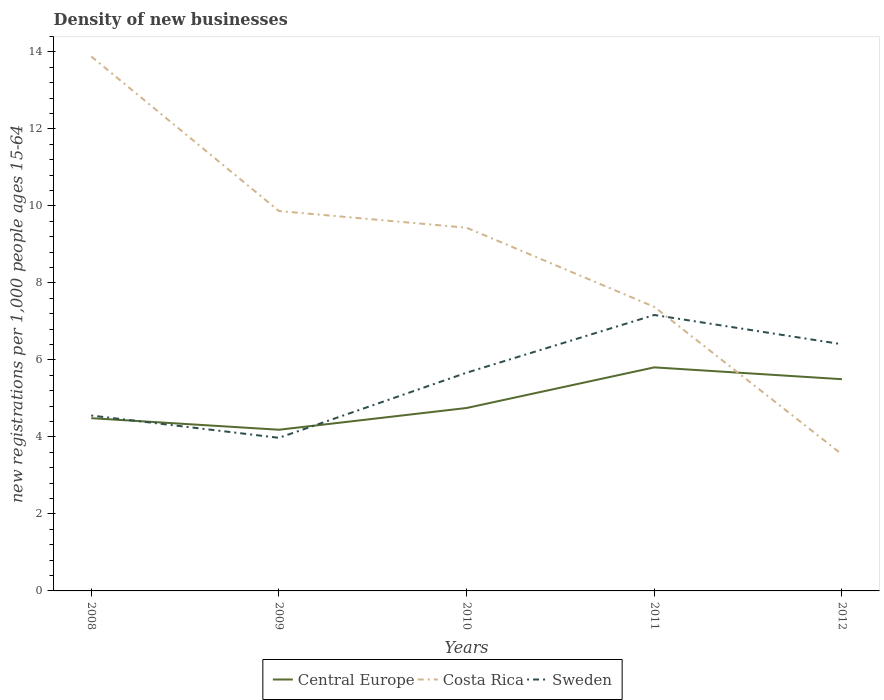How many different coloured lines are there?
Make the answer very short. 3. Does the line corresponding to Central Europe intersect with the line corresponding to Sweden?
Offer a terse response. Yes. Across all years, what is the maximum number of new registrations in Central Europe?
Make the answer very short. 4.19. What is the total number of new registrations in Central Europe in the graph?
Provide a short and direct response. -0.75. What is the difference between the highest and the second highest number of new registrations in Sweden?
Your response must be concise. 3.19. What is the difference between two consecutive major ticks on the Y-axis?
Provide a short and direct response. 2. Are the values on the major ticks of Y-axis written in scientific E-notation?
Give a very brief answer. No. Does the graph contain any zero values?
Give a very brief answer. No. Does the graph contain grids?
Provide a succinct answer. No. How many legend labels are there?
Offer a terse response. 3. What is the title of the graph?
Your response must be concise. Density of new businesses. What is the label or title of the Y-axis?
Ensure brevity in your answer.  New registrations per 1,0 people ages 15-64. What is the new registrations per 1,000 people ages 15-64 of Central Europe in 2008?
Make the answer very short. 4.49. What is the new registrations per 1,000 people ages 15-64 of Costa Rica in 2008?
Your answer should be compact. 13.88. What is the new registrations per 1,000 people ages 15-64 of Sweden in 2008?
Give a very brief answer. 4.56. What is the new registrations per 1,000 people ages 15-64 in Central Europe in 2009?
Ensure brevity in your answer.  4.19. What is the new registrations per 1,000 people ages 15-64 of Costa Rica in 2009?
Your answer should be very brief. 9.87. What is the new registrations per 1,000 people ages 15-64 in Sweden in 2009?
Offer a terse response. 3.98. What is the new registrations per 1,000 people ages 15-64 of Central Europe in 2010?
Your response must be concise. 4.75. What is the new registrations per 1,000 people ages 15-64 in Costa Rica in 2010?
Keep it short and to the point. 9.44. What is the new registrations per 1,000 people ages 15-64 in Sweden in 2010?
Offer a terse response. 5.67. What is the new registrations per 1,000 people ages 15-64 in Central Europe in 2011?
Keep it short and to the point. 5.81. What is the new registrations per 1,000 people ages 15-64 in Costa Rica in 2011?
Your answer should be very brief. 7.38. What is the new registrations per 1,000 people ages 15-64 in Sweden in 2011?
Your response must be concise. 7.17. What is the new registrations per 1,000 people ages 15-64 in Central Europe in 2012?
Give a very brief answer. 5.5. What is the new registrations per 1,000 people ages 15-64 of Costa Rica in 2012?
Make the answer very short. 3.55. What is the new registrations per 1,000 people ages 15-64 in Sweden in 2012?
Your answer should be compact. 6.41. Across all years, what is the maximum new registrations per 1,000 people ages 15-64 in Central Europe?
Offer a terse response. 5.81. Across all years, what is the maximum new registrations per 1,000 people ages 15-64 in Costa Rica?
Offer a very short reply. 13.88. Across all years, what is the maximum new registrations per 1,000 people ages 15-64 in Sweden?
Provide a short and direct response. 7.17. Across all years, what is the minimum new registrations per 1,000 people ages 15-64 in Central Europe?
Offer a terse response. 4.19. Across all years, what is the minimum new registrations per 1,000 people ages 15-64 of Costa Rica?
Make the answer very short. 3.55. Across all years, what is the minimum new registrations per 1,000 people ages 15-64 in Sweden?
Your answer should be compact. 3.98. What is the total new registrations per 1,000 people ages 15-64 of Central Europe in the graph?
Provide a succinct answer. 24.73. What is the total new registrations per 1,000 people ages 15-64 of Costa Rica in the graph?
Make the answer very short. 44.11. What is the total new registrations per 1,000 people ages 15-64 in Sweden in the graph?
Your answer should be compact. 27.78. What is the difference between the new registrations per 1,000 people ages 15-64 of Central Europe in 2008 and that in 2009?
Your answer should be very brief. 0.3. What is the difference between the new registrations per 1,000 people ages 15-64 of Costa Rica in 2008 and that in 2009?
Make the answer very short. 4.01. What is the difference between the new registrations per 1,000 people ages 15-64 of Sweden in 2008 and that in 2009?
Ensure brevity in your answer.  0.58. What is the difference between the new registrations per 1,000 people ages 15-64 in Central Europe in 2008 and that in 2010?
Offer a terse response. -0.26. What is the difference between the new registrations per 1,000 people ages 15-64 of Costa Rica in 2008 and that in 2010?
Your answer should be very brief. 4.45. What is the difference between the new registrations per 1,000 people ages 15-64 in Sweden in 2008 and that in 2010?
Offer a very short reply. -1.11. What is the difference between the new registrations per 1,000 people ages 15-64 in Central Europe in 2008 and that in 2011?
Offer a terse response. -1.32. What is the difference between the new registrations per 1,000 people ages 15-64 in Costa Rica in 2008 and that in 2011?
Offer a very short reply. 6.5. What is the difference between the new registrations per 1,000 people ages 15-64 of Sweden in 2008 and that in 2011?
Your response must be concise. -2.61. What is the difference between the new registrations per 1,000 people ages 15-64 in Central Europe in 2008 and that in 2012?
Make the answer very short. -1.01. What is the difference between the new registrations per 1,000 people ages 15-64 of Costa Rica in 2008 and that in 2012?
Make the answer very short. 10.34. What is the difference between the new registrations per 1,000 people ages 15-64 of Sweden in 2008 and that in 2012?
Provide a short and direct response. -1.85. What is the difference between the new registrations per 1,000 people ages 15-64 in Central Europe in 2009 and that in 2010?
Your answer should be very brief. -0.57. What is the difference between the new registrations per 1,000 people ages 15-64 of Costa Rica in 2009 and that in 2010?
Provide a short and direct response. 0.43. What is the difference between the new registrations per 1,000 people ages 15-64 in Sweden in 2009 and that in 2010?
Your answer should be compact. -1.69. What is the difference between the new registrations per 1,000 people ages 15-64 in Central Europe in 2009 and that in 2011?
Give a very brief answer. -1.62. What is the difference between the new registrations per 1,000 people ages 15-64 of Costa Rica in 2009 and that in 2011?
Keep it short and to the point. 2.49. What is the difference between the new registrations per 1,000 people ages 15-64 of Sweden in 2009 and that in 2011?
Give a very brief answer. -3.19. What is the difference between the new registrations per 1,000 people ages 15-64 of Central Europe in 2009 and that in 2012?
Your response must be concise. -1.31. What is the difference between the new registrations per 1,000 people ages 15-64 of Costa Rica in 2009 and that in 2012?
Give a very brief answer. 6.32. What is the difference between the new registrations per 1,000 people ages 15-64 of Sweden in 2009 and that in 2012?
Your answer should be compact. -2.43. What is the difference between the new registrations per 1,000 people ages 15-64 in Central Europe in 2010 and that in 2011?
Offer a terse response. -1.06. What is the difference between the new registrations per 1,000 people ages 15-64 of Costa Rica in 2010 and that in 2011?
Offer a terse response. 2.06. What is the difference between the new registrations per 1,000 people ages 15-64 of Sweden in 2010 and that in 2011?
Keep it short and to the point. -1.5. What is the difference between the new registrations per 1,000 people ages 15-64 in Central Europe in 2010 and that in 2012?
Make the answer very short. -0.75. What is the difference between the new registrations per 1,000 people ages 15-64 of Costa Rica in 2010 and that in 2012?
Offer a very short reply. 5.89. What is the difference between the new registrations per 1,000 people ages 15-64 in Sweden in 2010 and that in 2012?
Offer a very short reply. -0.74. What is the difference between the new registrations per 1,000 people ages 15-64 of Central Europe in 2011 and that in 2012?
Keep it short and to the point. 0.31. What is the difference between the new registrations per 1,000 people ages 15-64 in Costa Rica in 2011 and that in 2012?
Provide a succinct answer. 3.83. What is the difference between the new registrations per 1,000 people ages 15-64 of Sweden in 2011 and that in 2012?
Provide a succinct answer. 0.76. What is the difference between the new registrations per 1,000 people ages 15-64 of Central Europe in 2008 and the new registrations per 1,000 people ages 15-64 of Costa Rica in 2009?
Your response must be concise. -5.38. What is the difference between the new registrations per 1,000 people ages 15-64 of Central Europe in 2008 and the new registrations per 1,000 people ages 15-64 of Sweden in 2009?
Your answer should be very brief. 0.51. What is the difference between the new registrations per 1,000 people ages 15-64 of Costa Rica in 2008 and the new registrations per 1,000 people ages 15-64 of Sweden in 2009?
Offer a very short reply. 9.91. What is the difference between the new registrations per 1,000 people ages 15-64 of Central Europe in 2008 and the new registrations per 1,000 people ages 15-64 of Costa Rica in 2010?
Keep it short and to the point. -4.95. What is the difference between the new registrations per 1,000 people ages 15-64 in Central Europe in 2008 and the new registrations per 1,000 people ages 15-64 in Sweden in 2010?
Your answer should be very brief. -1.18. What is the difference between the new registrations per 1,000 people ages 15-64 in Costa Rica in 2008 and the new registrations per 1,000 people ages 15-64 in Sweden in 2010?
Offer a terse response. 8.21. What is the difference between the new registrations per 1,000 people ages 15-64 of Central Europe in 2008 and the new registrations per 1,000 people ages 15-64 of Costa Rica in 2011?
Offer a very short reply. -2.89. What is the difference between the new registrations per 1,000 people ages 15-64 of Central Europe in 2008 and the new registrations per 1,000 people ages 15-64 of Sweden in 2011?
Give a very brief answer. -2.68. What is the difference between the new registrations per 1,000 people ages 15-64 in Costa Rica in 2008 and the new registrations per 1,000 people ages 15-64 in Sweden in 2011?
Ensure brevity in your answer.  6.72. What is the difference between the new registrations per 1,000 people ages 15-64 in Central Europe in 2008 and the new registrations per 1,000 people ages 15-64 in Costa Rica in 2012?
Offer a very short reply. 0.94. What is the difference between the new registrations per 1,000 people ages 15-64 in Central Europe in 2008 and the new registrations per 1,000 people ages 15-64 in Sweden in 2012?
Your answer should be compact. -1.92. What is the difference between the new registrations per 1,000 people ages 15-64 of Costa Rica in 2008 and the new registrations per 1,000 people ages 15-64 of Sweden in 2012?
Offer a terse response. 7.47. What is the difference between the new registrations per 1,000 people ages 15-64 in Central Europe in 2009 and the new registrations per 1,000 people ages 15-64 in Costa Rica in 2010?
Ensure brevity in your answer.  -5.25. What is the difference between the new registrations per 1,000 people ages 15-64 of Central Europe in 2009 and the new registrations per 1,000 people ages 15-64 of Sweden in 2010?
Your answer should be very brief. -1.48. What is the difference between the new registrations per 1,000 people ages 15-64 in Costa Rica in 2009 and the new registrations per 1,000 people ages 15-64 in Sweden in 2010?
Offer a terse response. 4.2. What is the difference between the new registrations per 1,000 people ages 15-64 of Central Europe in 2009 and the new registrations per 1,000 people ages 15-64 of Costa Rica in 2011?
Your answer should be very brief. -3.19. What is the difference between the new registrations per 1,000 people ages 15-64 of Central Europe in 2009 and the new registrations per 1,000 people ages 15-64 of Sweden in 2011?
Your answer should be very brief. -2.98. What is the difference between the new registrations per 1,000 people ages 15-64 in Costa Rica in 2009 and the new registrations per 1,000 people ages 15-64 in Sweden in 2011?
Your response must be concise. 2.7. What is the difference between the new registrations per 1,000 people ages 15-64 in Central Europe in 2009 and the new registrations per 1,000 people ages 15-64 in Costa Rica in 2012?
Offer a terse response. 0.64. What is the difference between the new registrations per 1,000 people ages 15-64 in Central Europe in 2009 and the new registrations per 1,000 people ages 15-64 in Sweden in 2012?
Offer a terse response. -2.22. What is the difference between the new registrations per 1,000 people ages 15-64 in Costa Rica in 2009 and the new registrations per 1,000 people ages 15-64 in Sweden in 2012?
Ensure brevity in your answer.  3.46. What is the difference between the new registrations per 1,000 people ages 15-64 in Central Europe in 2010 and the new registrations per 1,000 people ages 15-64 in Costa Rica in 2011?
Make the answer very short. -2.63. What is the difference between the new registrations per 1,000 people ages 15-64 of Central Europe in 2010 and the new registrations per 1,000 people ages 15-64 of Sweden in 2011?
Provide a short and direct response. -2.42. What is the difference between the new registrations per 1,000 people ages 15-64 of Costa Rica in 2010 and the new registrations per 1,000 people ages 15-64 of Sweden in 2011?
Provide a succinct answer. 2.27. What is the difference between the new registrations per 1,000 people ages 15-64 of Central Europe in 2010 and the new registrations per 1,000 people ages 15-64 of Costa Rica in 2012?
Provide a succinct answer. 1.2. What is the difference between the new registrations per 1,000 people ages 15-64 of Central Europe in 2010 and the new registrations per 1,000 people ages 15-64 of Sweden in 2012?
Ensure brevity in your answer.  -1.66. What is the difference between the new registrations per 1,000 people ages 15-64 in Costa Rica in 2010 and the new registrations per 1,000 people ages 15-64 in Sweden in 2012?
Give a very brief answer. 3.03. What is the difference between the new registrations per 1,000 people ages 15-64 of Central Europe in 2011 and the new registrations per 1,000 people ages 15-64 of Costa Rica in 2012?
Give a very brief answer. 2.26. What is the difference between the new registrations per 1,000 people ages 15-64 in Central Europe in 2011 and the new registrations per 1,000 people ages 15-64 in Sweden in 2012?
Make the answer very short. -0.6. What is the average new registrations per 1,000 people ages 15-64 in Central Europe per year?
Your answer should be compact. 4.95. What is the average new registrations per 1,000 people ages 15-64 in Costa Rica per year?
Provide a succinct answer. 8.82. What is the average new registrations per 1,000 people ages 15-64 of Sweden per year?
Your answer should be compact. 5.56. In the year 2008, what is the difference between the new registrations per 1,000 people ages 15-64 in Central Europe and new registrations per 1,000 people ages 15-64 in Costa Rica?
Your response must be concise. -9.4. In the year 2008, what is the difference between the new registrations per 1,000 people ages 15-64 in Central Europe and new registrations per 1,000 people ages 15-64 in Sweden?
Your answer should be very brief. -0.07. In the year 2008, what is the difference between the new registrations per 1,000 people ages 15-64 of Costa Rica and new registrations per 1,000 people ages 15-64 of Sweden?
Provide a short and direct response. 9.33. In the year 2009, what is the difference between the new registrations per 1,000 people ages 15-64 of Central Europe and new registrations per 1,000 people ages 15-64 of Costa Rica?
Keep it short and to the point. -5.68. In the year 2009, what is the difference between the new registrations per 1,000 people ages 15-64 of Central Europe and new registrations per 1,000 people ages 15-64 of Sweden?
Your response must be concise. 0.21. In the year 2009, what is the difference between the new registrations per 1,000 people ages 15-64 in Costa Rica and new registrations per 1,000 people ages 15-64 in Sweden?
Offer a terse response. 5.89. In the year 2010, what is the difference between the new registrations per 1,000 people ages 15-64 of Central Europe and new registrations per 1,000 people ages 15-64 of Costa Rica?
Your answer should be very brief. -4.68. In the year 2010, what is the difference between the new registrations per 1,000 people ages 15-64 of Central Europe and new registrations per 1,000 people ages 15-64 of Sweden?
Your answer should be very brief. -0.92. In the year 2010, what is the difference between the new registrations per 1,000 people ages 15-64 in Costa Rica and new registrations per 1,000 people ages 15-64 in Sweden?
Give a very brief answer. 3.77. In the year 2011, what is the difference between the new registrations per 1,000 people ages 15-64 in Central Europe and new registrations per 1,000 people ages 15-64 in Costa Rica?
Provide a short and direct response. -1.57. In the year 2011, what is the difference between the new registrations per 1,000 people ages 15-64 in Central Europe and new registrations per 1,000 people ages 15-64 in Sweden?
Offer a very short reply. -1.36. In the year 2011, what is the difference between the new registrations per 1,000 people ages 15-64 in Costa Rica and new registrations per 1,000 people ages 15-64 in Sweden?
Your answer should be very brief. 0.21. In the year 2012, what is the difference between the new registrations per 1,000 people ages 15-64 of Central Europe and new registrations per 1,000 people ages 15-64 of Costa Rica?
Provide a succinct answer. 1.95. In the year 2012, what is the difference between the new registrations per 1,000 people ages 15-64 of Central Europe and new registrations per 1,000 people ages 15-64 of Sweden?
Keep it short and to the point. -0.91. In the year 2012, what is the difference between the new registrations per 1,000 people ages 15-64 of Costa Rica and new registrations per 1,000 people ages 15-64 of Sweden?
Keep it short and to the point. -2.86. What is the ratio of the new registrations per 1,000 people ages 15-64 of Central Europe in 2008 to that in 2009?
Ensure brevity in your answer.  1.07. What is the ratio of the new registrations per 1,000 people ages 15-64 of Costa Rica in 2008 to that in 2009?
Your answer should be compact. 1.41. What is the ratio of the new registrations per 1,000 people ages 15-64 of Sweden in 2008 to that in 2009?
Provide a succinct answer. 1.15. What is the ratio of the new registrations per 1,000 people ages 15-64 in Central Europe in 2008 to that in 2010?
Ensure brevity in your answer.  0.94. What is the ratio of the new registrations per 1,000 people ages 15-64 in Costa Rica in 2008 to that in 2010?
Make the answer very short. 1.47. What is the ratio of the new registrations per 1,000 people ages 15-64 of Sweden in 2008 to that in 2010?
Give a very brief answer. 0.8. What is the ratio of the new registrations per 1,000 people ages 15-64 in Central Europe in 2008 to that in 2011?
Provide a succinct answer. 0.77. What is the ratio of the new registrations per 1,000 people ages 15-64 in Costa Rica in 2008 to that in 2011?
Make the answer very short. 1.88. What is the ratio of the new registrations per 1,000 people ages 15-64 of Sweden in 2008 to that in 2011?
Offer a very short reply. 0.64. What is the ratio of the new registrations per 1,000 people ages 15-64 of Central Europe in 2008 to that in 2012?
Make the answer very short. 0.82. What is the ratio of the new registrations per 1,000 people ages 15-64 of Costa Rica in 2008 to that in 2012?
Ensure brevity in your answer.  3.91. What is the ratio of the new registrations per 1,000 people ages 15-64 of Sweden in 2008 to that in 2012?
Keep it short and to the point. 0.71. What is the ratio of the new registrations per 1,000 people ages 15-64 of Central Europe in 2009 to that in 2010?
Provide a succinct answer. 0.88. What is the ratio of the new registrations per 1,000 people ages 15-64 in Costa Rica in 2009 to that in 2010?
Offer a terse response. 1.05. What is the ratio of the new registrations per 1,000 people ages 15-64 in Sweden in 2009 to that in 2010?
Your answer should be very brief. 0.7. What is the ratio of the new registrations per 1,000 people ages 15-64 of Central Europe in 2009 to that in 2011?
Provide a short and direct response. 0.72. What is the ratio of the new registrations per 1,000 people ages 15-64 of Costa Rica in 2009 to that in 2011?
Make the answer very short. 1.34. What is the ratio of the new registrations per 1,000 people ages 15-64 in Sweden in 2009 to that in 2011?
Your answer should be compact. 0.55. What is the ratio of the new registrations per 1,000 people ages 15-64 of Central Europe in 2009 to that in 2012?
Provide a succinct answer. 0.76. What is the ratio of the new registrations per 1,000 people ages 15-64 of Costa Rica in 2009 to that in 2012?
Your answer should be compact. 2.78. What is the ratio of the new registrations per 1,000 people ages 15-64 in Sweden in 2009 to that in 2012?
Offer a very short reply. 0.62. What is the ratio of the new registrations per 1,000 people ages 15-64 in Central Europe in 2010 to that in 2011?
Provide a short and direct response. 0.82. What is the ratio of the new registrations per 1,000 people ages 15-64 in Costa Rica in 2010 to that in 2011?
Provide a succinct answer. 1.28. What is the ratio of the new registrations per 1,000 people ages 15-64 of Sweden in 2010 to that in 2011?
Offer a terse response. 0.79. What is the ratio of the new registrations per 1,000 people ages 15-64 of Central Europe in 2010 to that in 2012?
Provide a succinct answer. 0.86. What is the ratio of the new registrations per 1,000 people ages 15-64 of Costa Rica in 2010 to that in 2012?
Offer a terse response. 2.66. What is the ratio of the new registrations per 1,000 people ages 15-64 in Sweden in 2010 to that in 2012?
Your answer should be very brief. 0.88. What is the ratio of the new registrations per 1,000 people ages 15-64 in Central Europe in 2011 to that in 2012?
Keep it short and to the point. 1.06. What is the ratio of the new registrations per 1,000 people ages 15-64 of Costa Rica in 2011 to that in 2012?
Offer a very short reply. 2.08. What is the ratio of the new registrations per 1,000 people ages 15-64 of Sweden in 2011 to that in 2012?
Your response must be concise. 1.12. What is the difference between the highest and the second highest new registrations per 1,000 people ages 15-64 in Central Europe?
Your answer should be very brief. 0.31. What is the difference between the highest and the second highest new registrations per 1,000 people ages 15-64 of Costa Rica?
Give a very brief answer. 4.01. What is the difference between the highest and the second highest new registrations per 1,000 people ages 15-64 of Sweden?
Provide a succinct answer. 0.76. What is the difference between the highest and the lowest new registrations per 1,000 people ages 15-64 in Central Europe?
Keep it short and to the point. 1.62. What is the difference between the highest and the lowest new registrations per 1,000 people ages 15-64 of Costa Rica?
Provide a short and direct response. 10.34. What is the difference between the highest and the lowest new registrations per 1,000 people ages 15-64 in Sweden?
Offer a terse response. 3.19. 